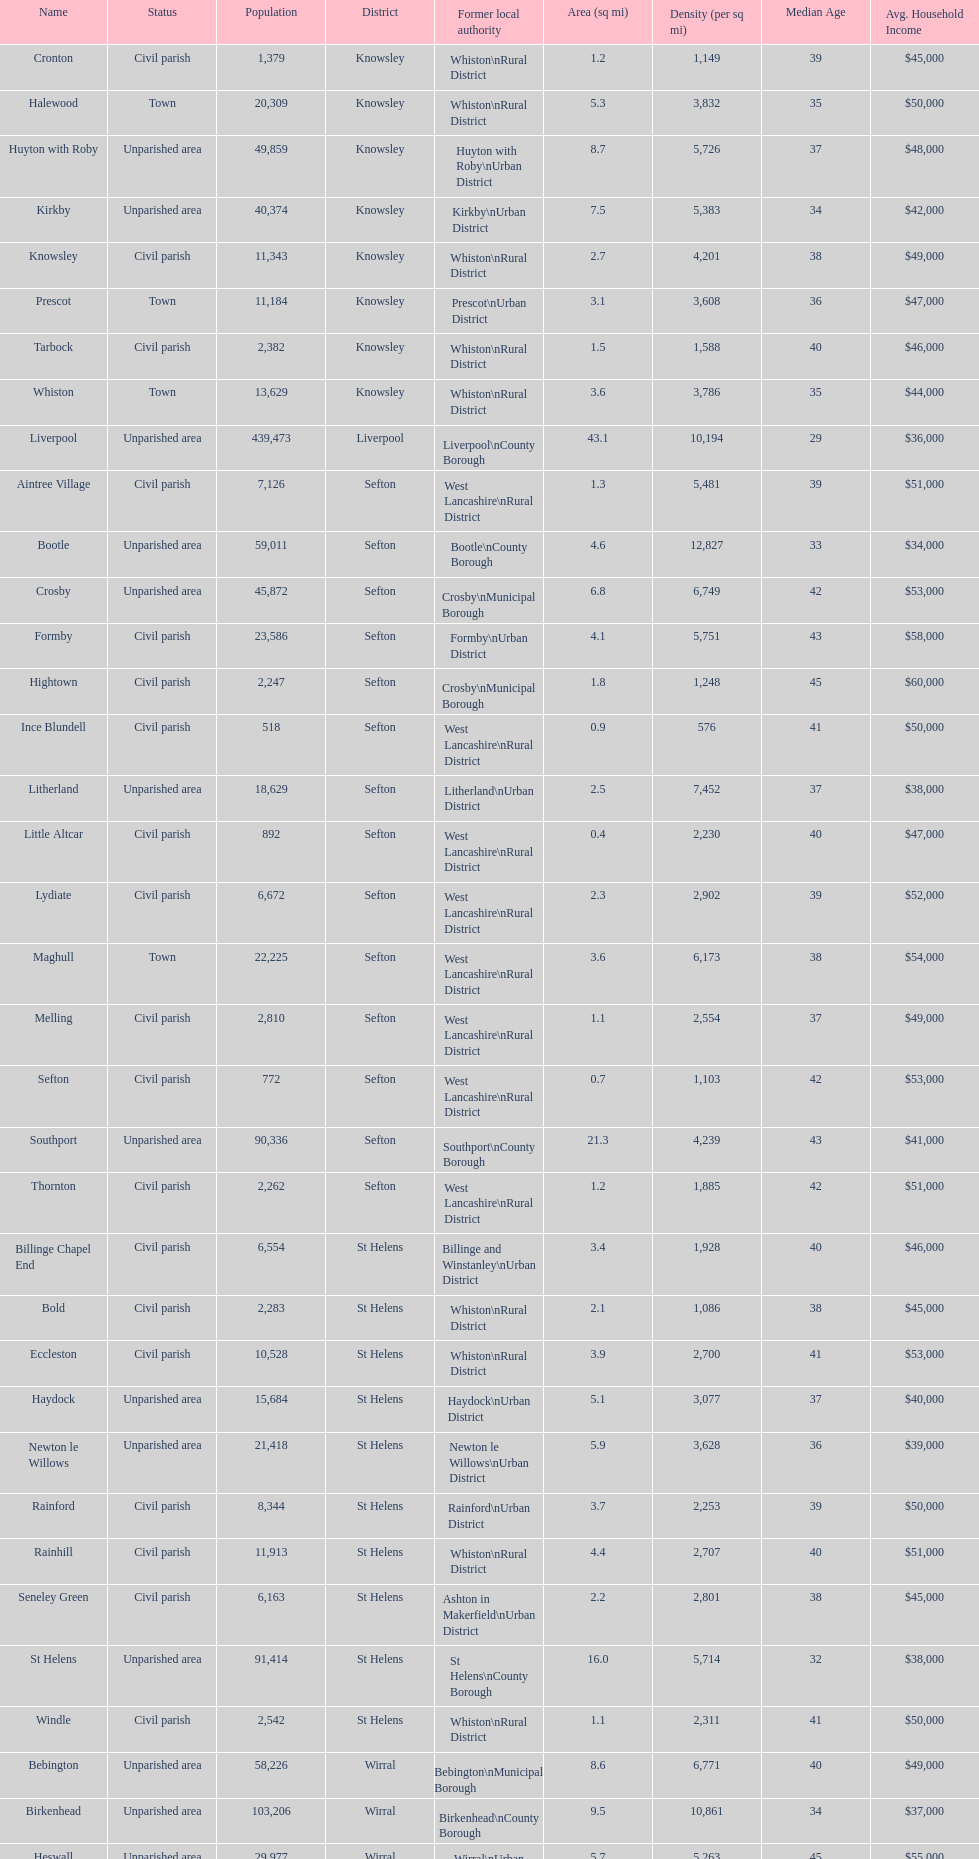Tell me the number of residents in formby. 23,586. 